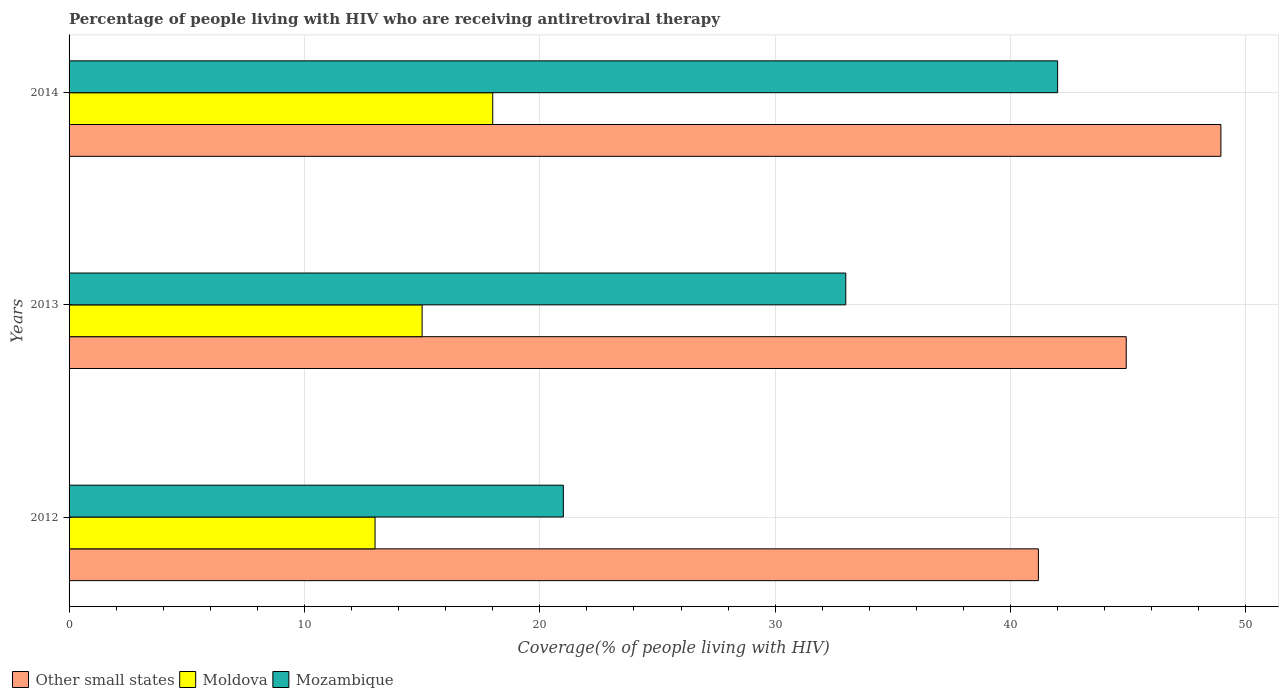Are the number of bars per tick equal to the number of legend labels?
Ensure brevity in your answer.  Yes. Are the number of bars on each tick of the Y-axis equal?
Provide a succinct answer. Yes. How many bars are there on the 2nd tick from the top?
Offer a very short reply. 3. What is the percentage of the HIV infected people who are receiving antiretroviral therapy in Mozambique in 2013?
Your answer should be compact. 33. Across all years, what is the maximum percentage of the HIV infected people who are receiving antiretroviral therapy in Moldova?
Offer a very short reply. 18. Across all years, what is the minimum percentage of the HIV infected people who are receiving antiretroviral therapy in Mozambique?
Offer a very short reply. 21. In which year was the percentage of the HIV infected people who are receiving antiretroviral therapy in Moldova maximum?
Ensure brevity in your answer.  2014. In which year was the percentage of the HIV infected people who are receiving antiretroviral therapy in Other small states minimum?
Your response must be concise. 2012. What is the total percentage of the HIV infected people who are receiving antiretroviral therapy in Mozambique in the graph?
Provide a short and direct response. 96. What is the difference between the percentage of the HIV infected people who are receiving antiretroviral therapy in Mozambique in 2012 and that in 2014?
Your answer should be very brief. -21. What is the difference between the percentage of the HIV infected people who are receiving antiretroviral therapy in Other small states in 2014 and the percentage of the HIV infected people who are receiving antiretroviral therapy in Moldova in 2012?
Make the answer very short. 35.94. What is the average percentage of the HIV infected people who are receiving antiretroviral therapy in Other small states per year?
Offer a terse response. 45.01. In the year 2013, what is the difference between the percentage of the HIV infected people who are receiving antiretroviral therapy in Other small states and percentage of the HIV infected people who are receiving antiretroviral therapy in Moldova?
Keep it short and to the point. 29.92. In how many years, is the percentage of the HIV infected people who are receiving antiretroviral therapy in Other small states greater than 26 %?
Your answer should be very brief. 3. What is the ratio of the percentage of the HIV infected people who are receiving antiretroviral therapy in Mozambique in 2013 to that in 2014?
Keep it short and to the point. 0.79. Is the difference between the percentage of the HIV infected people who are receiving antiretroviral therapy in Other small states in 2012 and 2014 greater than the difference between the percentage of the HIV infected people who are receiving antiretroviral therapy in Moldova in 2012 and 2014?
Your response must be concise. No. What is the difference between the highest and the lowest percentage of the HIV infected people who are receiving antiretroviral therapy in Mozambique?
Make the answer very short. 21. In how many years, is the percentage of the HIV infected people who are receiving antiretroviral therapy in Moldova greater than the average percentage of the HIV infected people who are receiving antiretroviral therapy in Moldova taken over all years?
Provide a succinct answer. 1. Is the sum of the percentage of the HIV infected people who are receiving antiretroviral therapy in Mozambique in 2013 and 2014 greater than the maximum percentage of the HIV infected people who are receiving antiretroviral therapy in Other small states across all years?
Provide a short and direct response. Yes. What does the 3rd bar from the top in 2013 represents?
Keep it short and to the point. Other small states. What does the 2nd bar from the bottom in 2012 represents?
Your response must be concise. Moldova. How many bars are there?
Offer a very short reply. 9. Are all the bars in the graph horizontal?
Your answer should be very brief. Yes. How many years are there in the graph?
Make the answer very short. 3. What is the difference between two consecutive major ticks on the X-axis?
Offer a terse response. 10. Are the values on the major ticks of X-axis written in scientific E-notation?
Ensure brevity in your answer.  No. Does the graph contain any zero values?
Provide a short and direct response. No. Does the graph contain grids?
Ensure brevity in your answer.  Yes. How are the legend labels stacked?
Your response must be concise. Horizontal. What is the title of the graph?
Give a very brief answer. Percentage of people living with HIV who are receiving antiretroviral therapy. What is the label or title of the X-axis?
Make the answer very short. Coverage(% of people living with HIV). What is the label or title of the Y-axis?
Provide a short and direct response. Years. What is the Coverage(% of people living with HIV) in Other small states in 2012?
Keep it short and to the point. 41.18. What is the Coverage(% of people living with HIV) of Moldova in 2012?
Give a very brief answer. 13. What is the Coverage(% of people living with HIV) in Other small states in 2013?
Your answer should be compact. 44.92. What is the Coverage(% of people living with HIV) of Moldova in 2013?
Offer a very short reply. 15. What is the Coverage(% of people living with HIV) in Mozambique in 2013?
Your answer should be very brief. 33. What is the Coverage(% of people living with HIV) of Other small states in 2014?
Provide a short and direct response. 48.94. What is the Coverage(% of people living with HIV) of Mozambique in 2014?
Offer a terse response. 42. Across all years, what is the maximum Coverage(% of people living with HIV) of Other small states?
Provide a succinct answer. 48.94. Across all years, what is the maximum Coverage(% of people living with HIV) in Moldova?
Your answer should be very brief. 18. Across all years, what is the minimum Coverage(% of people living with HIV) in Other small states?
Your response must be concise. 41.18. What is the total Coverage(% of people living with HIV) in Other small states in the graph?
Offer a very short reply. 135.04. What is the total Coverage(% of people living with HIV) of Mozambique in the graph?
Offer a terse response. 96. What is the difference between the Coverage(% of people living with HIV) in Other small states in 2012 and that in 2013?
Offer a terse response. -3.73. What is the difference between the Coverage(% of people living with HIV) in Moldova in 2012 and that in 2013?
Provide a short and direct response. -2. What is the difference between the Coverage(% of people living with HIV) of Other small states in 2012 and that in 2014?
Your answer should be compact. -7.75. What is the difference between the Coverage(% of people living with HIV) in Mozambique in 2012 and that in 2014?
Offer a terse response. -21. What is the difference between the Coverage(% of people living with HIV) of Other small states in 2013 and that in 2014?
Your answer should be very brief. -4.02. What is the difference between the Coverage(% of people living with HIV) of Moldova in 2013 and that in 2014?
Provide a short and direct response. -3. What is the difference between the Coverage(% of people living with HIV) in Mozambique in 2013 and that in 2014?
Give a very brief answer. -9. What is the difference between the Coverage(% of people living with HIV) in Other small states in 2012 and the Coverage(% of people living with HIV) in Moldova in 2013?
Your answer should be very brief. 26.18. What is the difference between the Coverage(% of people living with HIV) in Other small states in 2012 and the Coverage(% of people living with HIV) in Mozambique in 2013?
Offer a terse response. 8.18. What is the difference between the Coverage(% of people living with HIV) of Moldova in 2012 and the Coverage(% of people living with HIV) of Mozambique in 2013?
Keep it short and to the point. -20. What is the difference between the Coverage(% of people living with HIV) in Other small states in 2012 and the Coverage(% of people living with HIV) in Moldova in 2014?
Ensure brevity in your answer.  23.18. What is the difference between the Coverage(% of people living with HIV) in Other small states in 2012 and the Coverage(% of people living with HIV) in Mozambique in 2014?
Your response must be concise. -0.82. What is the difference between the Coverage(% of people living with HIV) of Other small states in 2013 and the Coverage(% of people living with HIV) of Moldova in 2014?
Your answer should be compact. 26.92. What is the difference between the Coverage(% of people living with HIV) of Other small states in 2013 and the Coverage(% of people living with HIV) of Mozambique in 2014?
Ensure brevity in your answer.  2.92. What is the difference between the Coverage(% of people living with HIV) of Moldova in 2013 and the Coverage(% of people living with HIV) of Mozambique in 2014?
Your answer should be very brief. -27. What is the average Coverage(% of people living with HIV) in Other small states per year?
Your answer should be compact. 45.01. What is the average Coverage(% of people living with HIV) in Moldova per year?
Your answer should be very brief. 15.33. What is the average Coverage(% of people living with HIV) of Mozambique per year?
Provide a succinct answer. 32. In the year 2012, what is the difference between the Coverage(% of people living with HIV) of Other small states and Coverage(% of people living with HIV) of Moldova?
Your answer should be compact. 28.18. In the year 2012, what is the difference between the Coverage(% of people living with HIV) in Other small states and Coverage(% of people living with HIV) in Mozambique?
Ensure brevity in your answer.  20.18. In the year 2012, what is the difference between the Coverage(% of people living with HIV) in Moldova and Coverage(% of people living with HIV) in Mozambique?
Keep it short and to the point. -8. In the year 2013, what is the difference between the Coverage(% of people living with HIV) of Other small states and Coverage(% of people living with HIV) of Moldova?
Your answer should be compact. 29.92. In the year 2013, what is the difference between the Coverage(% of people living with HIV) of Other small states and Coverage(% of people living with HIV) of Mozambique?
Offer a very short reply. 11.92. In the year 2014, what is the difference between the Coverage(% of people living with HIV) of Other small states and Coverage(% of people living with HIV) of Moldova?
Give a very brief answer. 30.94. In the year 2014, what is the difference between the Coverage(% of people living with HIV) in Other small states and Coverage(% of people living with HIV) in Mozambique?
Ensure brevity in your answer.  6.94. What is the ratio of the Coverage(% of people living with HIV) of Other small states in 2012 to that in 2013?
Your answer should be compact. 0.92. What is the ratio of the Coverage(% of people living with HIV) in Moldova in 2012 to that in 2013?
Ensure brevity in your answer.  0.87. What is the ratio of the Coverage(% of people living with HIV) in Mozambique in 2012 to that in 2013?
Make the answer very short. 0.64. What is the ratio of the Coverage(% of people living with HIV) of Other small states in 2012 to that in 2014?
Give a very brief answer. 0.84. What is the ratio of the Coverage(% of people living with HIV) of Moldova in 2012 to that in 2014?
Give a very brief answer. 0.72. What is the ratio of the Coverage(% of people living with HIV) in Mozambique in 2012 to that in 2014?
Offer a terse response. 0.5. What is the ratio of the Coverage(% of people living with HIV) of Other small states in 2013 to that in 2014?
Your answer should be compact. 0.92. What is the ratio of the Coverage(% of people living with HIV) in Mozambique in 2013 to that in 2014?
Keep it short and to the point. 0.79. What is the difference between the highest and the second highest Coverage(% of people living with HIV) of Other small states?
Ensure brevity in your answer.  4.02. What is the difference between the highest and the second highest Coverage(% of people living with HIV) in Moldova?
Offer a terse response. 3. What is the difference between the highest and the second highest Coverage(% of people living with HIV) in Mozambique?
Your answer should be compact. 9. What is the difference between the highest and the lowest Coverage(% of people living with HIV) in Other small states?
Your answer should be compact. 7.75. What is the difference between the highest and the lowest Coverage(% of people living with HIV) in Mozambique?
Offer a terse response. 21. 